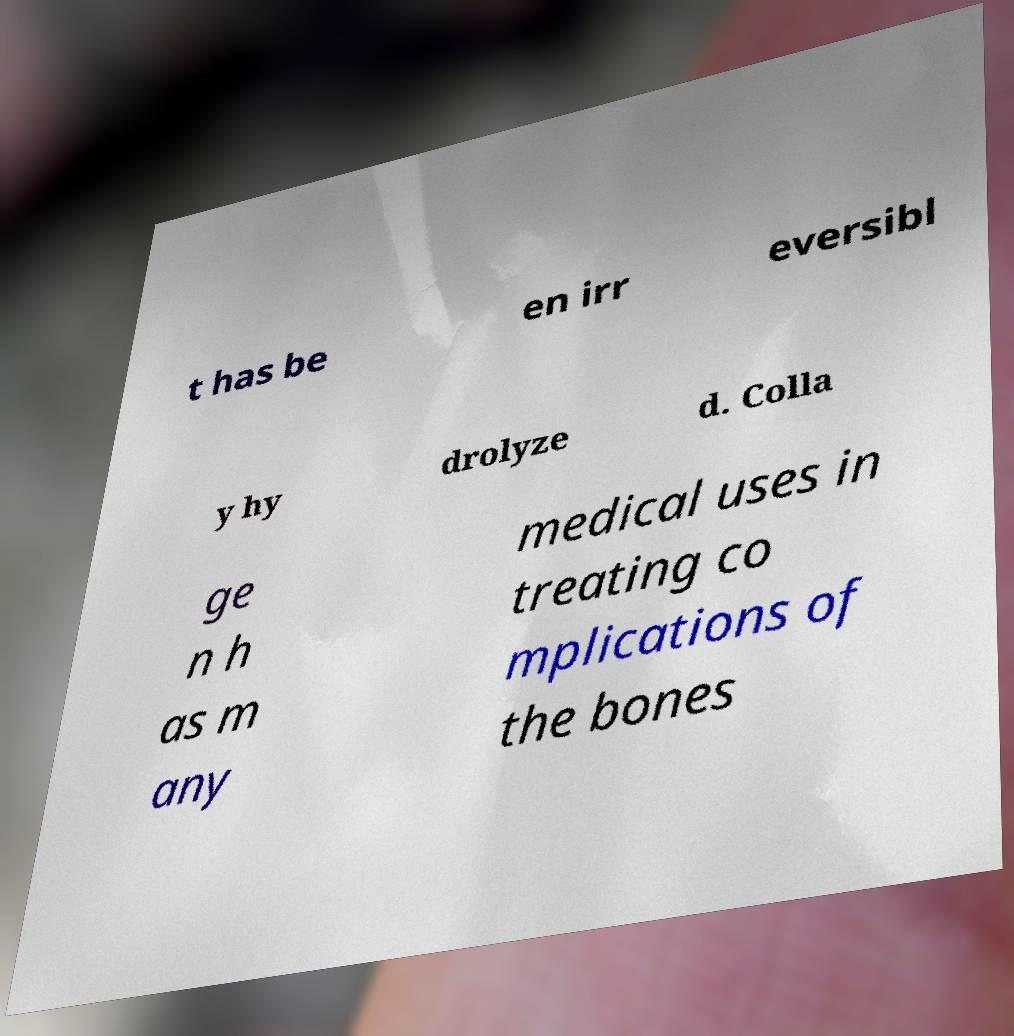For documentation purposes, I need the text within this image transcribed. Could you provide that? t has be en irr eversibl y hy drolyze d. Colla ge n h as m any medical uses in treating co mplications of the bones 